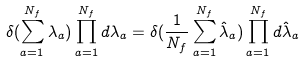Convert formula to latex. <formula><loc_0><loc_0><loc_500><loc_500>\delta ( \sum _ { a = 1 } ^ { N _ { f } } \lambda _ { a } ) \prod _ { a = 1 } ^ { N _ { f } } d \lambda _ { a } = \delta ( \frac { 1 } { N _ { f } } \sum _ { a = 1 } ^ { N _ { f } } \hat { \lambda } _ { a } ) \prod _ { a = 1 } ^ { N _ { f } } d \hat { \lambda } _ { a }</formula> 